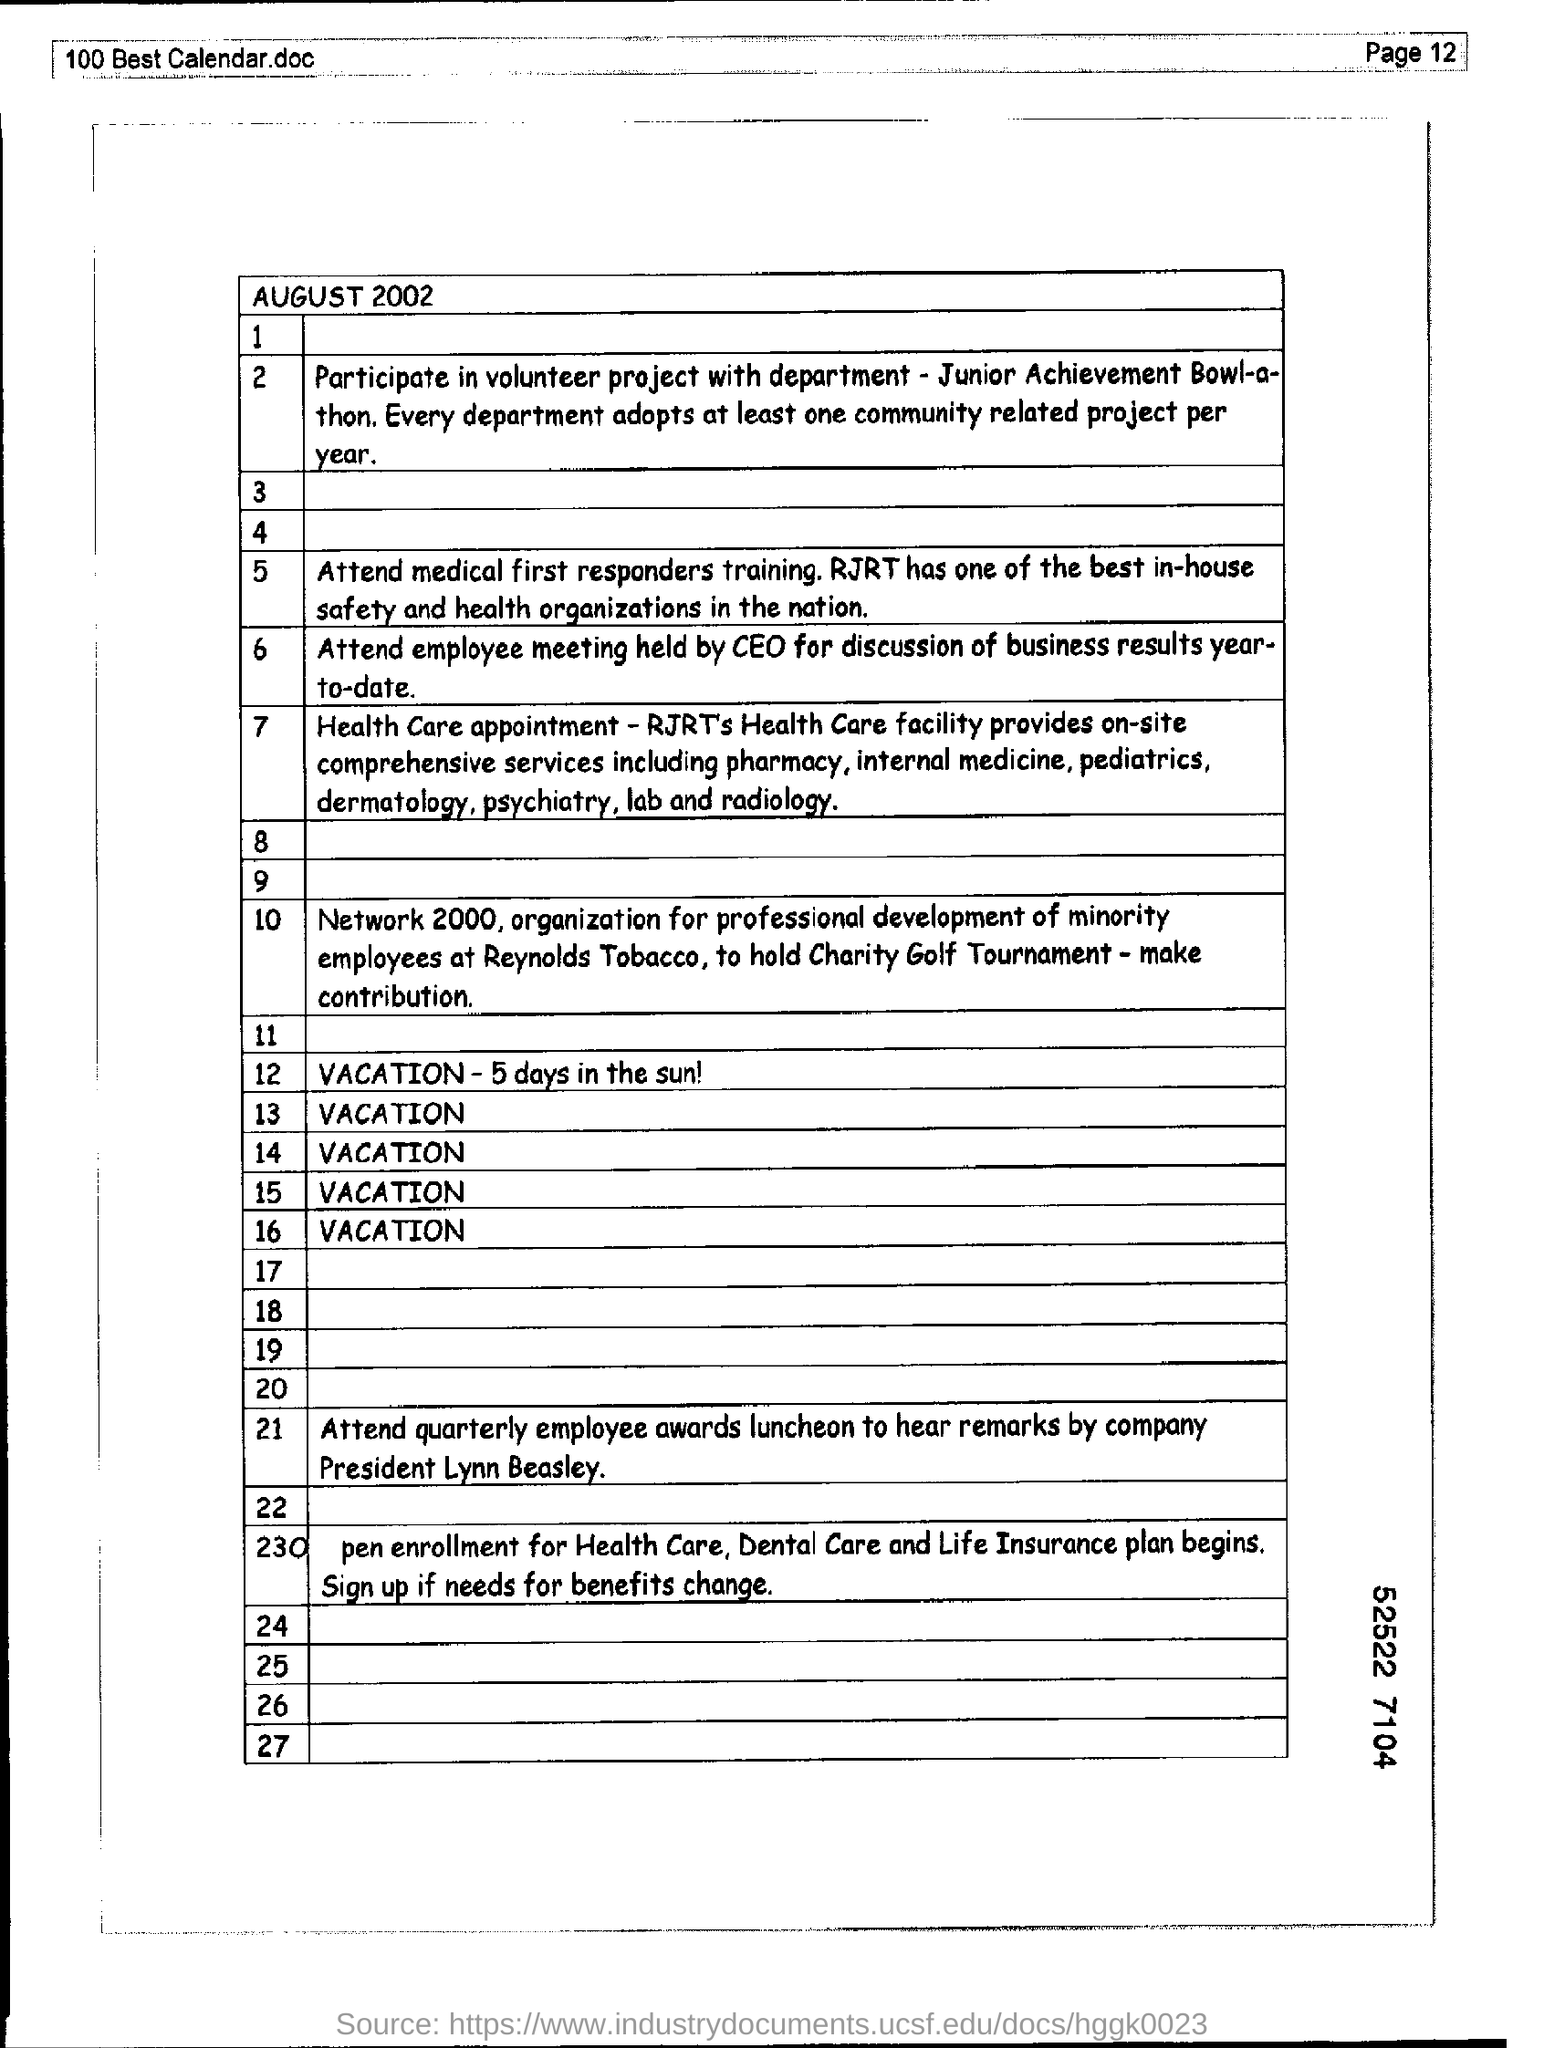What month and year this calender refering ?
Offer a very short reply. AUGUST 2002. Who has the best in-house safety and health organizations in the nation ?
Give a very brief answer. RJRT. 